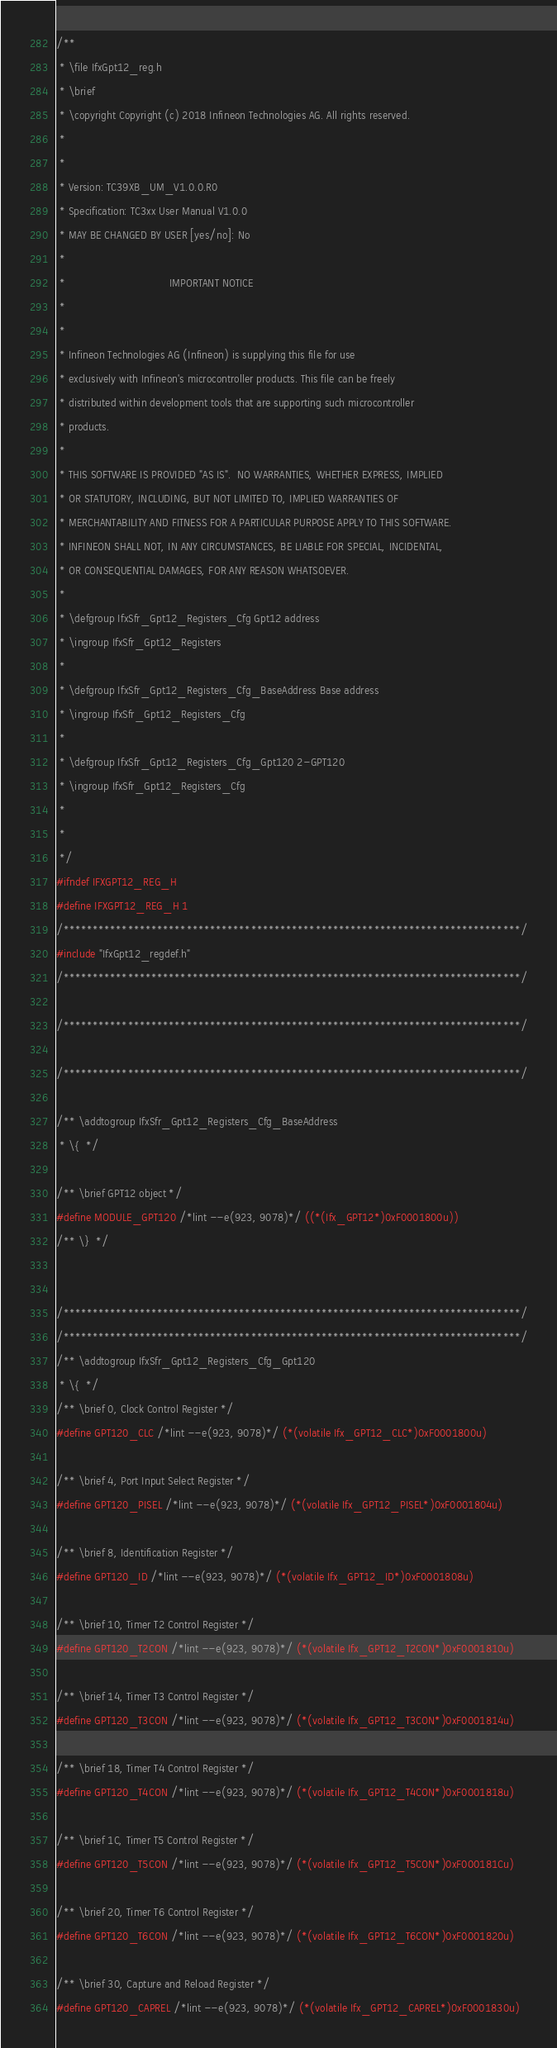Convert code to text. <code><loc_0><loc_0><loc_500><loc_500><_C_>/**
 * \file IfxGpt12_reg.h
 * \brief
 * \copyright Copyright (c) 2018 Infineon Technologies AG. All rights reserved.
 *
 *
 * Version: TC39XB_UM_V1.0.0.R0
 * Specification: TC3xx User Manual V1.0.0
 * MAY BE CHANGED BY USER [yes/no]: No
 *
 *                                 IMPORTANT NOTICE
 *
 *
 * Infineon Technologies AG (Infineon) is supplying this file for use
 * exclusively with Infineon's microcontroller products. This file can be freely
 * distributed within development tools that are supporting such microcontroller
 * products.
 *
 * THIS SOFTWARE IS PROVIDED "AS IS".  NO WARRANTIES, WHETHER EXPRESS, IMPLIED
 * OR STATUTORY, INCLUDING, BUT NOT LIMITED TO, IMPLIED WARRANTIES OF
 * MERCHANTABILITY AND FITNESS FOR A PARTICULAR PURPOSE APPLY TO THIS SOFTWARE.
 * INFINEON SHALL NOT, IN ANY CIRCUMSTANCES, BE LIABLE FOR SPECIAL, INCIDENTAL,
 * OR CONSEQUENTIAL DAMAGES, FOR ANY REASON WHATSOEVER.
 *
 * \defgroup IfxSfr_Gpt12_Registers_Cfg Gpt12 address
 * \ingroup IfxSfr_Gpt12_Registers
 * 
 * \defgroup IfxSfr_Gpt12_Registers_Cfg_BaseAddress Base address
 * \ingroup IfxSfr_Gpt12_Registers_Cfg
 *
 * \defgroup IfxSfr_Gpt12_Registers_Cfg_Gpt120 2-GPT120
 * \ingroup IfxSfr_Gpt12_Registers_Cfg
 *
 *
 */
#ifndef IFXGPT12_REG_H
#define IFXGPT12_REG_H 1
/******************************************************************************/
#include "IfxGpt12_regdef.h"
/******************************************************************************/

/******************************************************************************/

/******************************************************************************/

/** \addtogroup IfxSfr_Gpt12_Registers_Cfg_BaseAddress
 * \{  */

/** \brief GPT12 object */
#define MODULE_GPT120 /*lint --e(923, 9078)*/ ((*(Ifx_GPT12*)0xF0001800u))
/** \}  */


/******************************************************************************/
/******************************************************************************/
/** \addtogroup IfxSfr_Gpt12_Registers_Cfg_Gpt120
 * \{  */
/** \brief 0, Clock Control Register */
#define GPT120_CLC /*lint --e(923, 9078)*/ (*(volatile Ifx_GPT12_CLC*)0xF0001800u)

/** \brief 4, Port Input Select Register */
#define GPT120_PISEL /*lint --e(923, 9078)*/ (*(volatile Ifx_GPT12_PISEL*)0xF0001804u)

/** \brief 8, Identification Register */
#define GPT120_ID /*lint --e(923, 9078)*/ (*(volatile Ifx_GPT12_ID*)0xF0001808u)

/** \brief 10, Timer T2 Control Register */
#define GPT120_T2CON /*lint --e(923, 9078)*/ (*(volatile Ifx_GPT12_T2CON*)0xF0001810u)

/** \brief 14, Timer T3 Control Register */
#define GPT120_T3CON /*lint --e(923, 9078)*/ (*(volatile Ifx_GPT12_T3CON*)0xF0001814u)

/** \brief 18, Timer T4 Control Register */
#define GPT120_T4CON /*lint --e(923, 9078)*/ (*(volatile Ifx_GPT12_T4CON*)0xF0001818u)

/** \brief 1C, Timer T5 Control Register */
#define GPT120_T5CON /*lint --e(923, 9078)*/ (*(volatile Ifx_GPT12_T5CON*)0xF000181Cu)

/** \brief 20, Timer T6 Control Register */
#define GPT120_T6CON /*lint --e(923, 9078)*/ (*(volatile Ifx_GPT12_T6CON*)0xF0001820u)

/** \brief 30, Capture and Reload Register */
#define GPT120_CAPREL /*lint --e(923, 9078)*/ (*(volatile Ifx_GPT12_CAPREL*)0xF0001830u)
</code> 